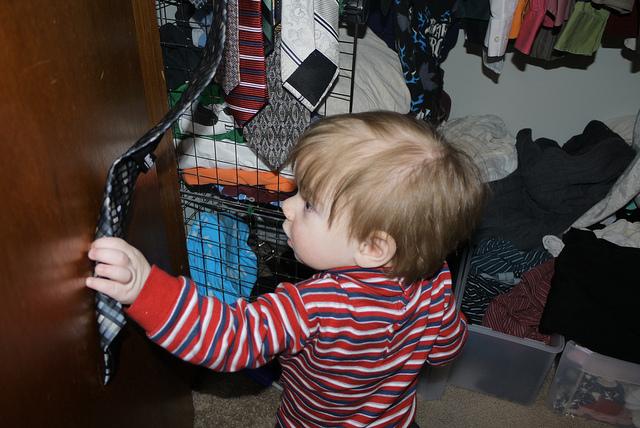Are there clothes in the plastic hampers?
Short answer required. Yes. Is the child holding a tie that he would wear?
Quick response, please. No. Is the child's shirt covered in stripes or spots?
Quick response, please. Stripes. 